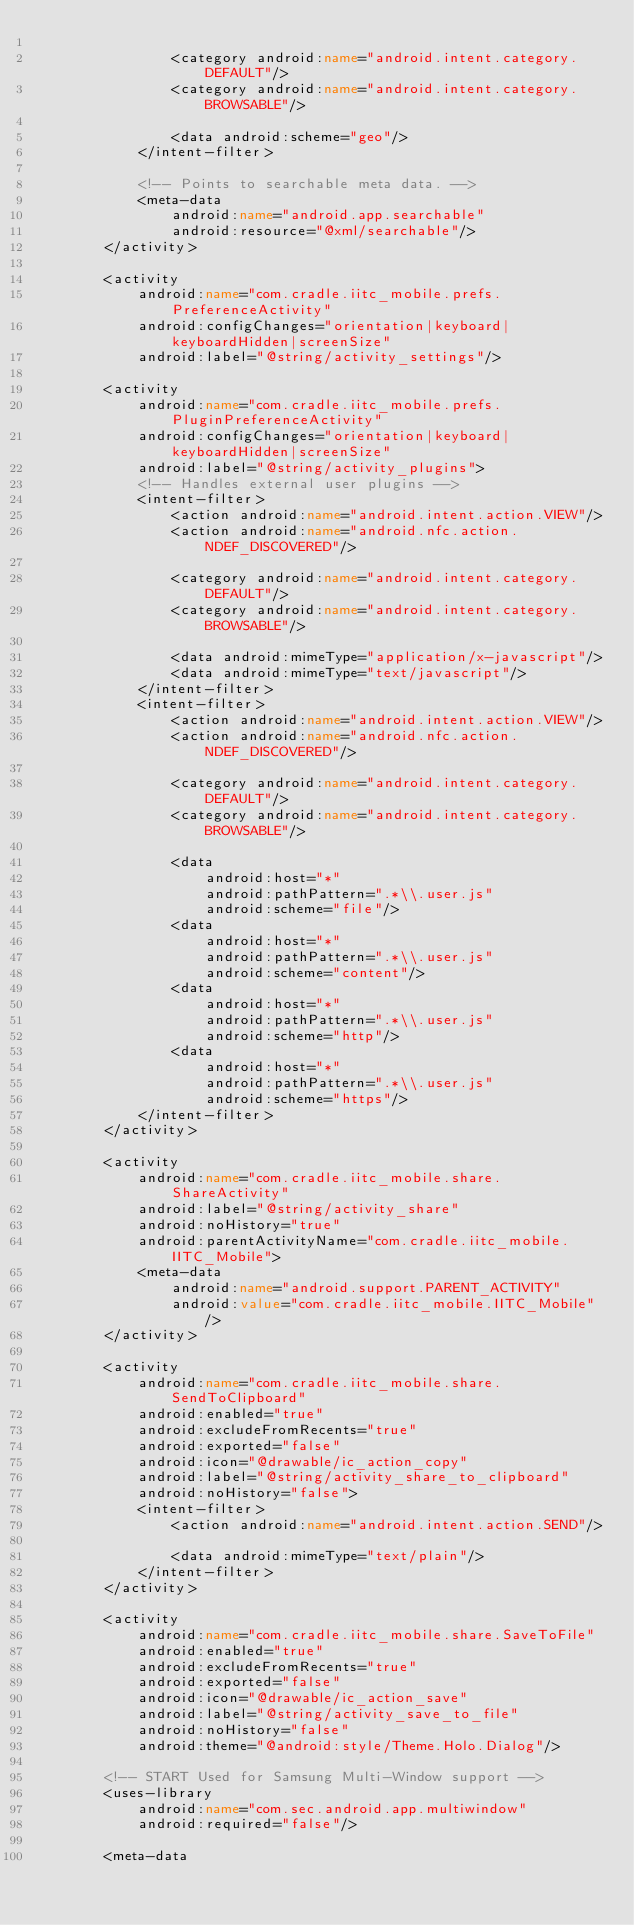Convert code to text. <code><loc_0><loc_0><loc_500><loc_500><_XML_>
                <category android:name="android.intent.category.DEFAULT"/>
                <category android:name="android.intent.category.BROWSABLE"/>

                <data android:scheme="geo"/>
            </intent-filter>

            <!-- Points to searchable meta data. -->
            <meta-data
                android:name="android.app.searchable"
                android:resource="@xml/searchable"/>
        </activity>

        <activity
            android:name="com.cradle.iitc_mobile.prefs.PreferenceActivity"
            android:configChanges="orientation|keyboard|keyboardHidden|screenSize"
            android:label="@string/activity_settings"/>

        <activity
            android:name="com.cradle.iitc_mobile.prefs.PluginPreferenceActivity"
            android:configChanges="orientation|keyboard|keyboardHidden|screenSize"
            android:label="@string/activity_plugins">
            <!-- Handles external user plugins -->
            <intent-filter>
                <action android:name="android.intent.action.VIEW"/>
                <action android:name="android.nfc.action.NDEF_DISCOVERED"/>

                <category android:name="android.intent.category.DEFAULT"/>
                <category android:name="android.intent.category.BROWSABLE"/>

                <data android:mimeType="application/x-javascript"/>
                <data android:mimeType="text/javascript"/>
            </intent-filter>
            <intent-filter>
                <action android:name="android.intent.action.VIEW"/>
                <action android:name="android.nfc.action.NDEF_DISCOVERED"/>

                <category android:name="android.intent.category.DEFAULT"/>
                <category android:name="android.intent.category.BROWSABLE"/>

                <data
                    android:host="*"
                    android:pathPattern=".*\\.user.js"
                    android:scheme="file"/>
                <data
                    android:host="*"
                    android:pathPattern=".*\\.user.js"
                    android:scheme="content"/>
                <data
                    android:host="*"
                    android:pathPattern=".*\\.user.js"
                    android:scheme="http"/>
                <data
                    android:host="*"
                    android:pathPattern=".*\\.user.js"
                    android:scheme="https"/>
            </intent-filter>
        </activity>

        <activity
            android:name="com.cradle.iitc_mobile.share.ShareActivity"
            android:label="@string/activity_share"
            android:noHistory="true"
            android:parentActivityName="com.cradle.iitc_mobile.IITC_Mobile">
            <meta-data
                android:name="android.support.PARENT_ACTIVITY"
                android:value="com.cradle.iitc_mobile.IITC_Mobile"/>
        </activity>

        <activity
            android:name="com.cradle.iitc_mobile.share.SendToClipboard"
            android:enabled="true"
            android:excludeFromRecents="true"
            android:exported="false"
            android:icon="@drawable/ic_action_copy"
            android:label="@string/activity_share_to_clipboard"
            android:noHistory="false">
            <intent-filter>
                <action android:name="android.intent.action.SEND"/>

                <data android:mimeType="text/plain"/>
            </intent-filter>
        </activity>

        <activity
            android:name="com.cradle.iitc_mobile.share.SaveToFile"
            android:enabled="true"
            android:excludeFromRecents="true"
            android:exported="false"
            android:icon="@drawable/ic_action_save"
            android:label="@string/activity_save_to_file"
            android:noHistory="false"
            android:theme="@android:style/Theme.Holo.Dialog"/>

        <!-- START Used for Samsung Multi-Window support -->
        <uses-library
            android:name="com.sec.android.app.multiwindow"
            android:required="false"/>

        <meta-data</code> 